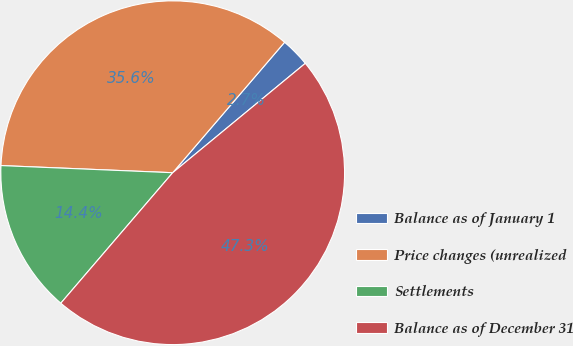Convert chart. <chart><loc_0><loc_0><loc_500><loc_500><pie_chart><fcel>Balance as of January 1<fcel>Price changes (unrealized<fcel>Settlements<fcel>Balance as of December 31<nl><fcel>2.74%<fcel>35.62%<fcel>14.38%<fcel>47.26%<nl></chart> 